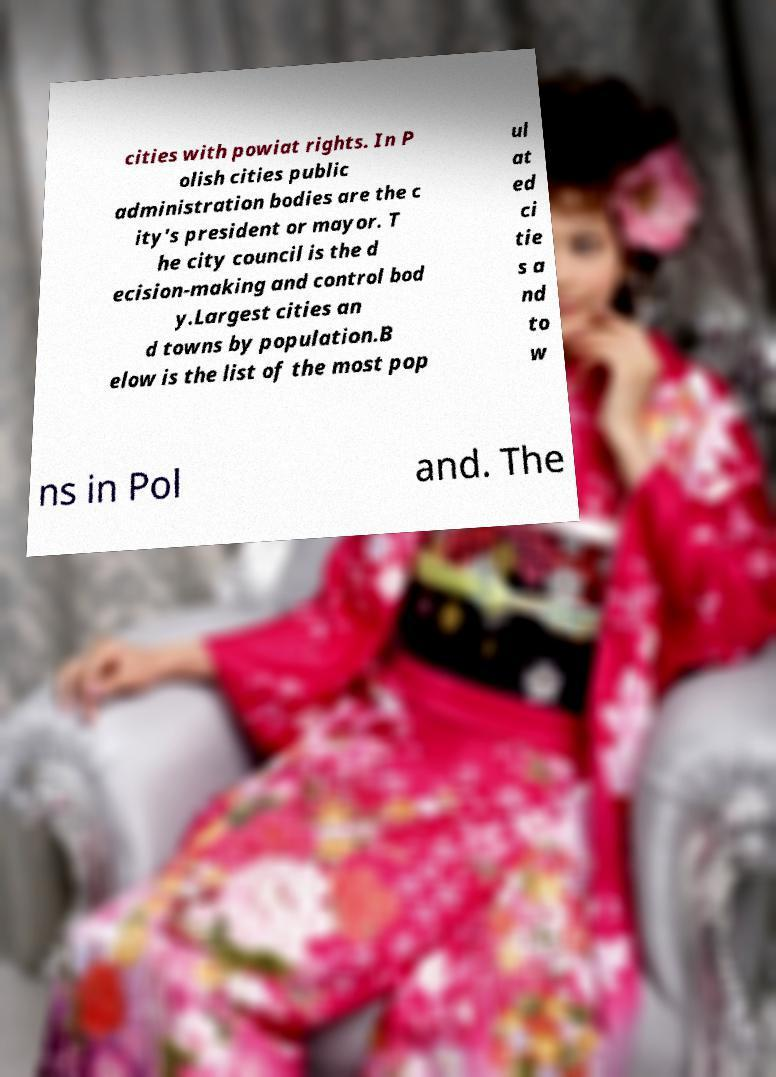Please identify and transcribe the text found in this image. cities with powiat rights. In P olish cities public administration bodies are the c ity's president or mayor. T he city council is the d ecision-making and control bod y.Largest cities an d towns by population.B elow is the list of the most pop ul at ed ci tie s a nd to w ns in Pol and. The 